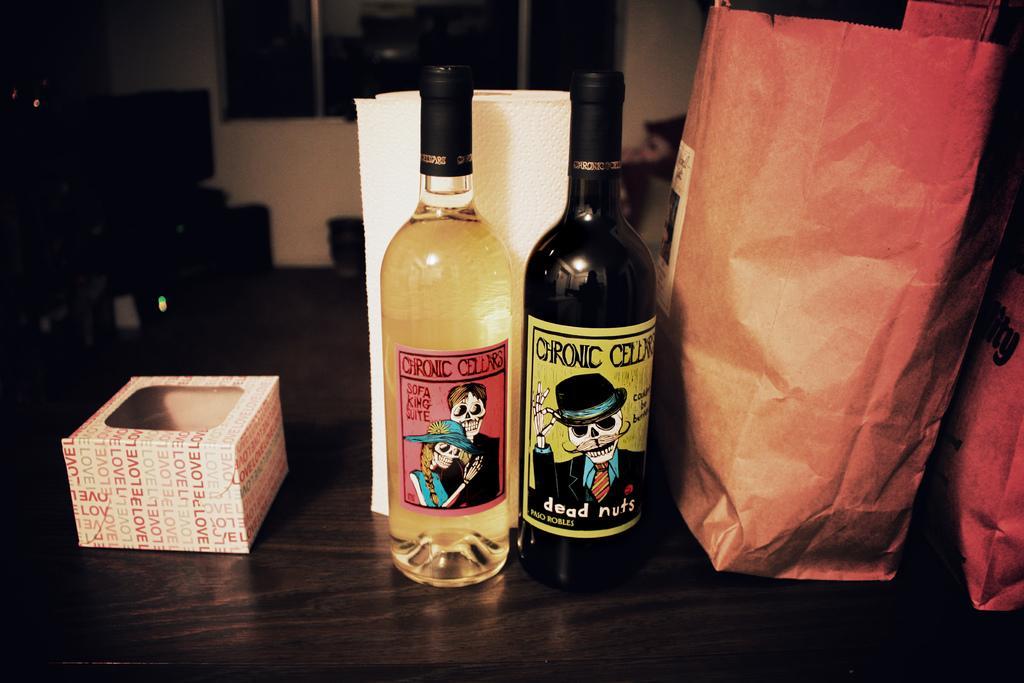Please provide a concise description of this image. Two glass bottles and one box and one cover, on the bottles there is a sticker where skeleton is present on them. It is sealed with caps, behind the bottles there's a window and a wall and some furniture. 